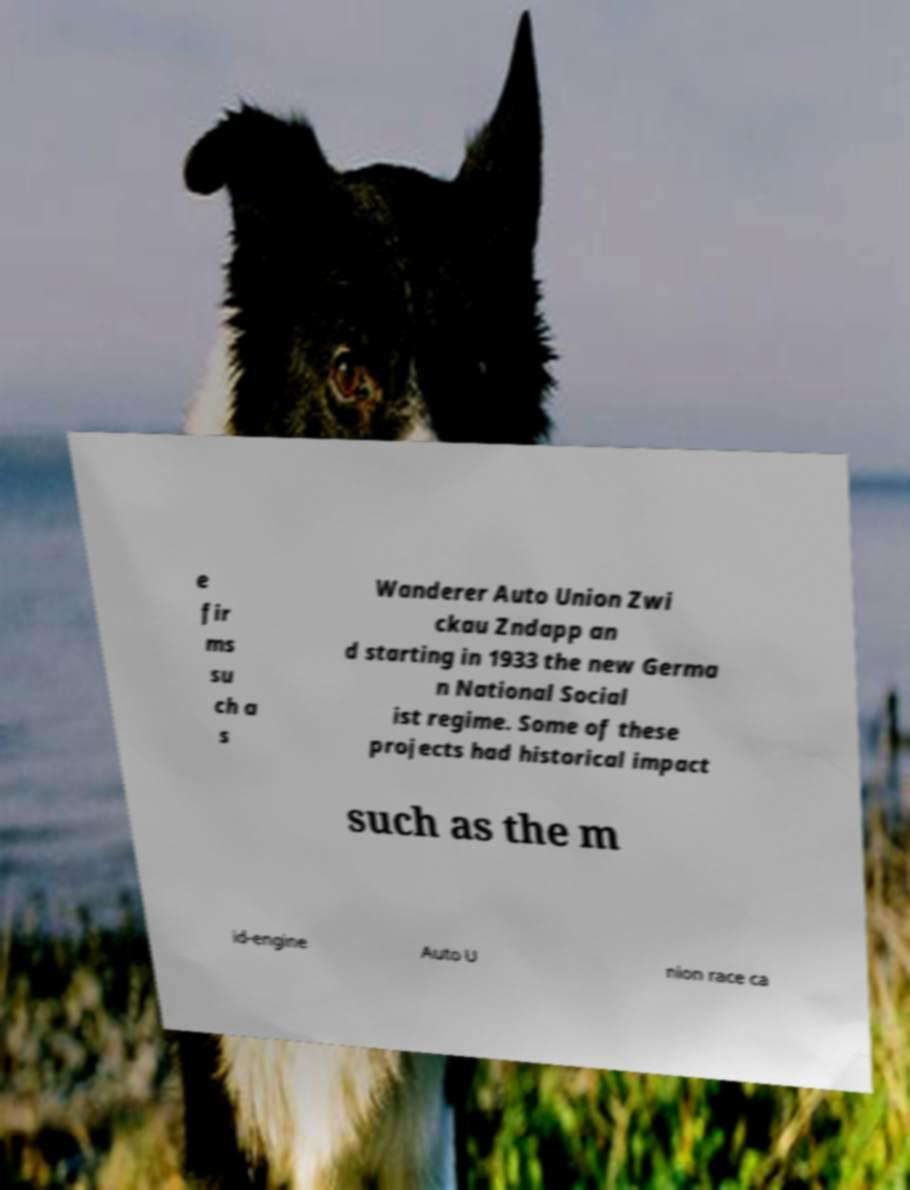Could you assist in decoding the text presented in this image and type it out clearly? e fir ms su ch a s Wanderer Auto Union Zwi ckau Zndapp an d starting in 1933 the new Germa n National Social ist regime. Some of these projects had historical impact such as the m id-engine Auto U nion race ca 